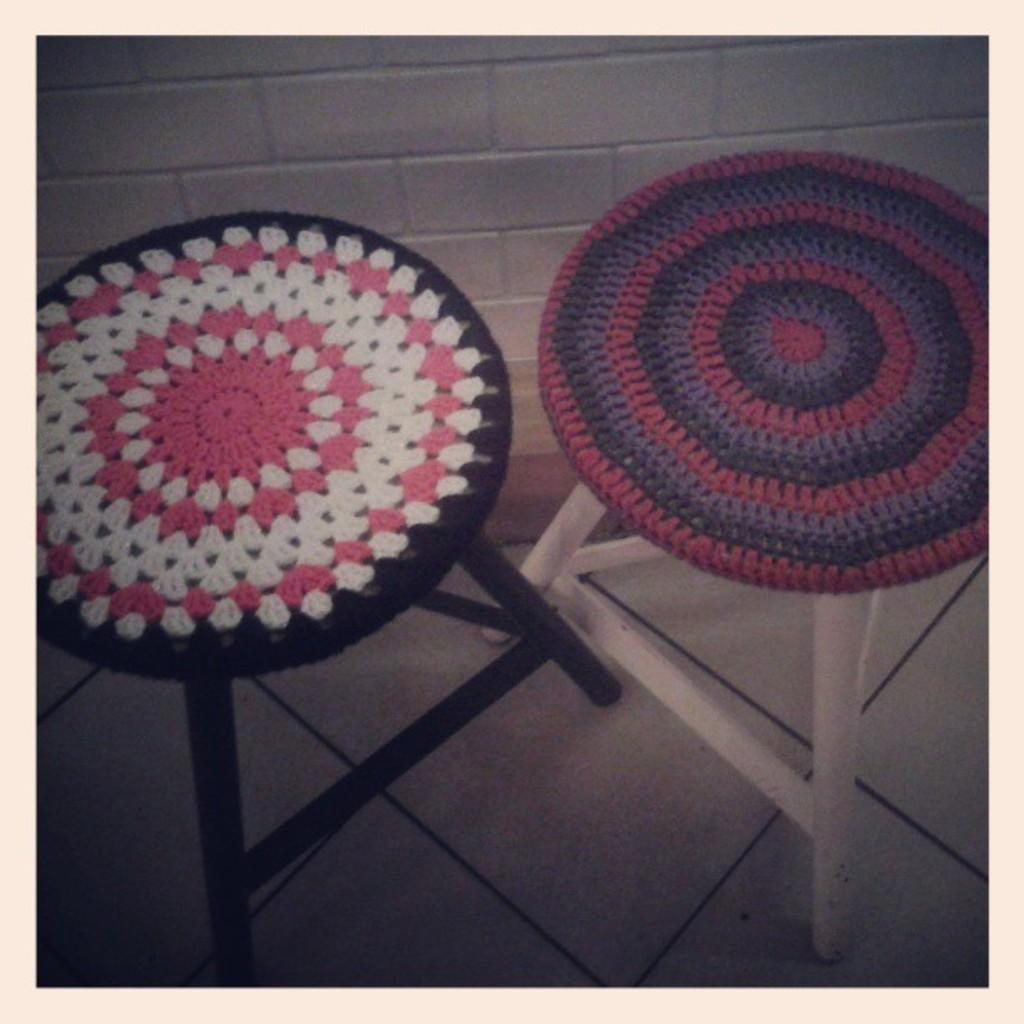What type of furniture is present in the image? There are stools in the image. What is placed on each stool? Each stool has a cloth on it. What material is used for the embroidery on the cloths? The cloths are embroidered with wool. Where is the stove located in the image? There is no stove present in the image. What type of ball is being used for the embroidery on the cloths? The cloths are embroidered with wool, not a ball, as the material used for the embroidery. 